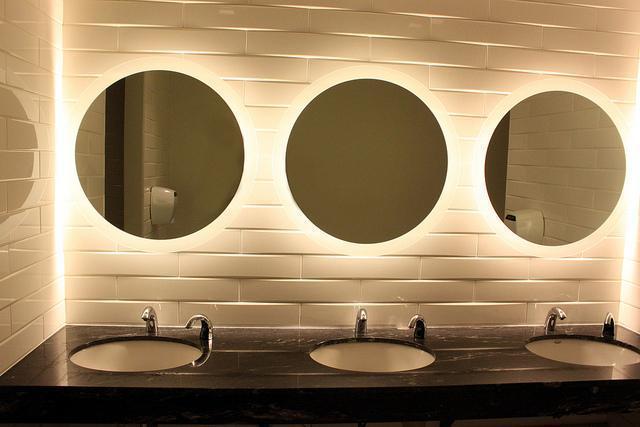How many sinks are there?
Give a very brief answer. 3. How many people have their hands showing?
Give a very brief answer. 0. 